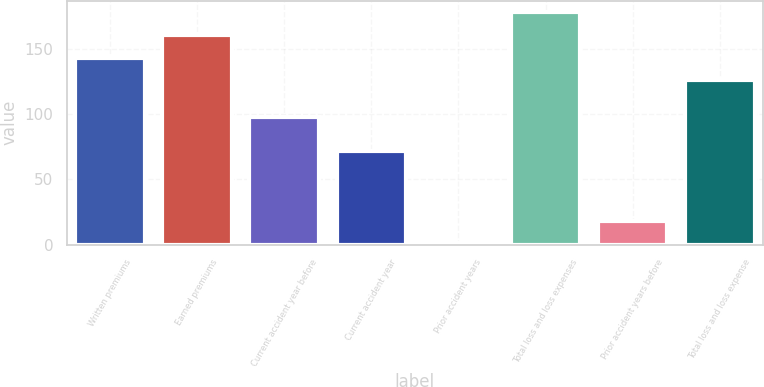<chart> <loc_0><loc_0><loc_500><loc_500><bar_chart><fcel>Written premiums<fcel>Earned premiums<fcel>Current accident year before<fcel>Current accident year<fcel>Prior accident years<fcel>Total loss and loss expenses<fcel>Prior accident years before<fcel>Total loss and loss expense<nl><fcel>143.4<fcel>160.8<fcel>98<fcel>72<fcel>1<fcel>178.2<fcel>18.4<fcel>126<nl></chart> 